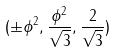<formula> <loc_0><loc_0><loc_500><loc_500>( \pm \phi ^ { 2 } , \frac { \phi ^ { 2 } } { \sqrt { 3 } } , \frac { 2 } { \sqrt { 3 } } )</formula> 